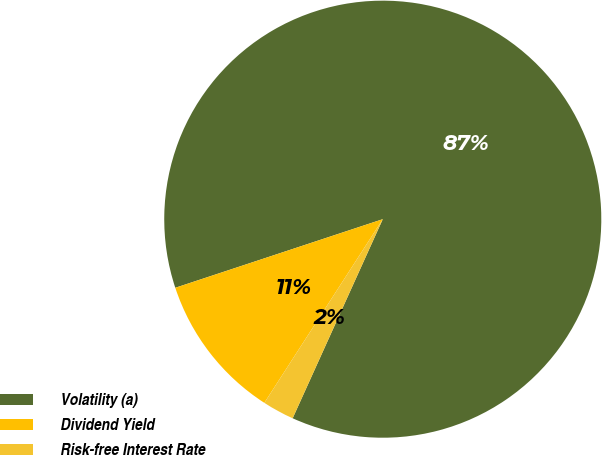Convert chart. <chart><loc_0><loc_0><loc_500><loc_500><pie_chart><fcel>Volatility (a)<fcel>Dividend Yield<fcel>Risk-free Interest Rate<nl><fcel>86.84%<fcel>10.8%<fcel>2.35%<nl></chart> 